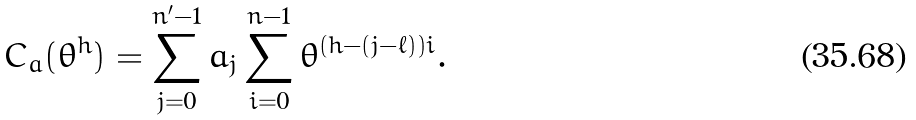<formula> <loc_0><loc_0><loc_500><loc_500>C _ { a } ( \theta ^ { h } ) = \sum _ { j = 0 } ^ { n ^ { \prime } - 1 } a _ { j } \sum _ { i = 0 } ^ { n - 1 } \theta ^ { ( h - ( j - \ell ) ) i } .</formula> 